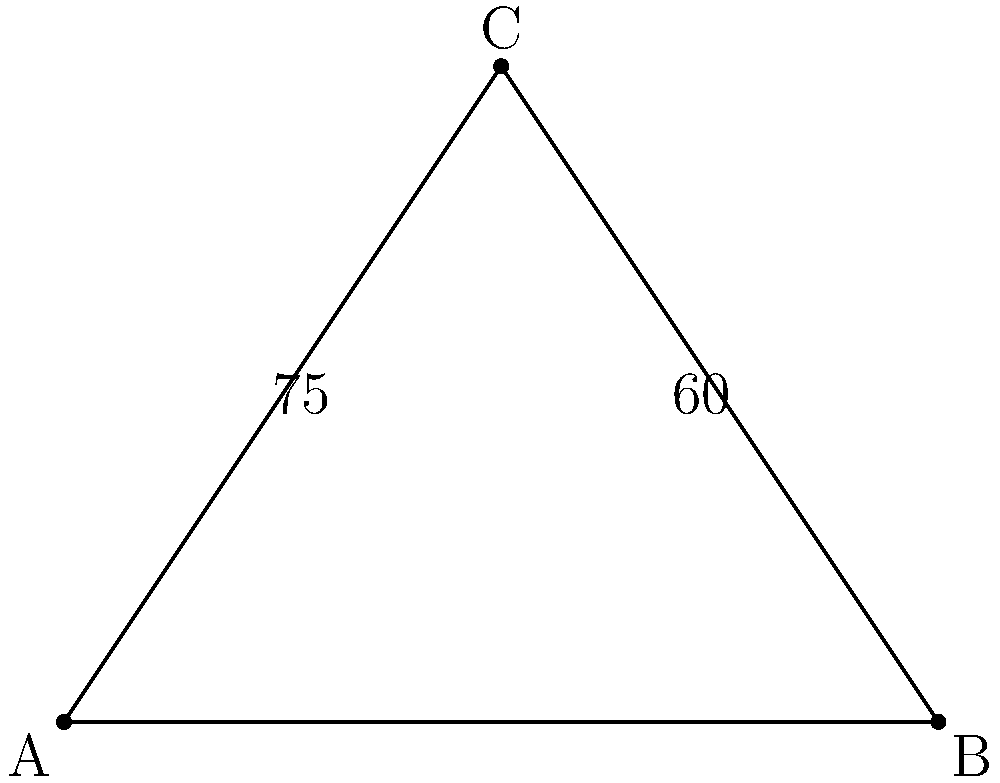While walking your grandparent's pet in a park, you notice two intersecting paths forming a triangle with a third path. If the angles between these paths are $60°$ and $75°$ as shown in the diagram, what is the measure of the third angle in the triangle? To solve this problem, let's follow these steps:

1) Recall that the sum of angles in a triangle is always $180°$.

2) We are given two angles in the triangle:
   - One angle is $60°$
   - Another angle is $75°$

3) Let's call the third angle $x°$.

4) We can set up an equation based on the fact that all angles in a triangle sum to $180°$:

   $60° + 75° + x° = 180°$

5) Simplify the left side of the equation:

   $135° + x° = 180°$

6) Subtract $135°$ from both sides:

   $x° = 180° - 135° = 45°$

Therefore, the measure of the third angle in the triangle is $45°$.
Answer: $45°$ 